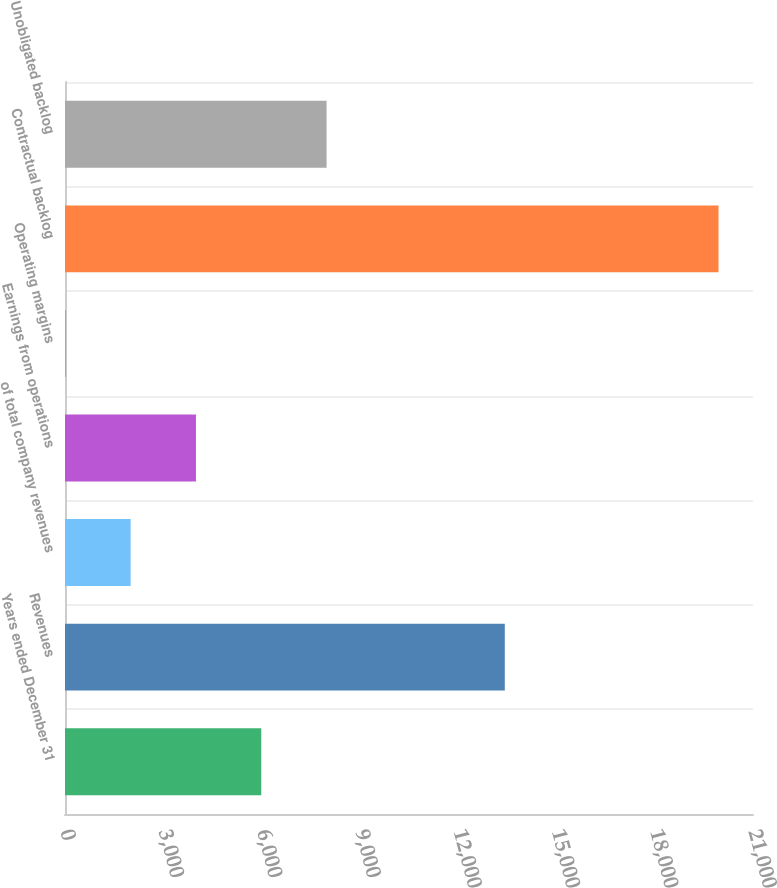<chart> <loc_0><loc_0><loc_500><loc_500><bar_chart><fcel>Years ended December 31<fcel>Revenues<fcel>of total company revenues<fcel>Earnings from operations<fcel>Operating margins<fcel>Contractual backlog<fcel>Unobligated backlog<nl><fcel>5990.96<fcel>13424<fcel>2003.52<fcel>3997.24<fcel>9.8<fcel>19947<fcel>7984.68<nl></chart> 